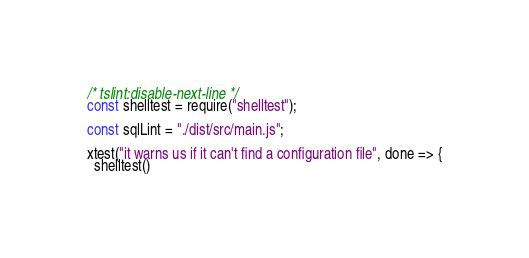Convert code to text. <code><loc_0><loc_0><loc_500><loc_500><_TypeScript_>/* tslint:disable-next-line */
const shelltest = require("shelltest");

const sqlLint = "./dist/src/main.js";

xtest("it warns us if it can't find a configuration file", done => {
  shelltest()</code> 